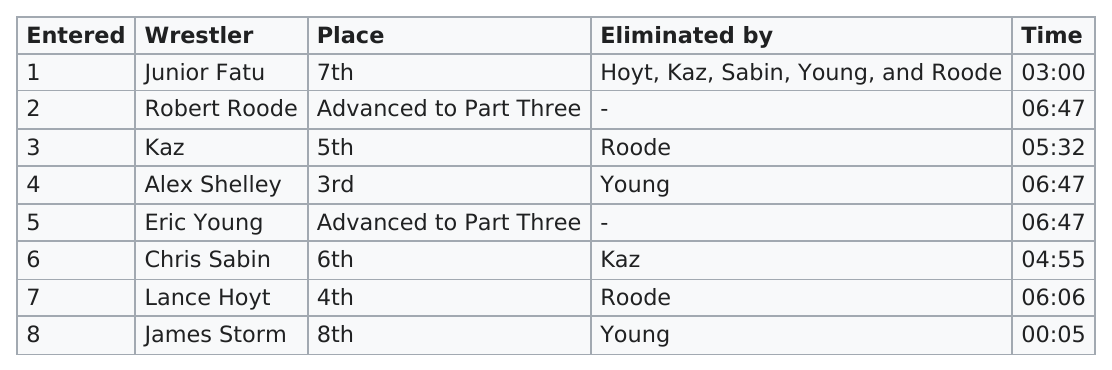Indicate a few pertinent items in this graphic. The wrestlers Alex Shelly, Robert Roode, and Eric Young all had the same time. Junior Fatu, a wrestler, was eliminated by a total of five wrestlers in a competition. There were 6 matches that lasted at least 4 minutes. Four tasks lasted for at least 6 minutes. Robert Roode and Eric Young were the wrestlers who did not get eliminated in part two of the battle royal. 